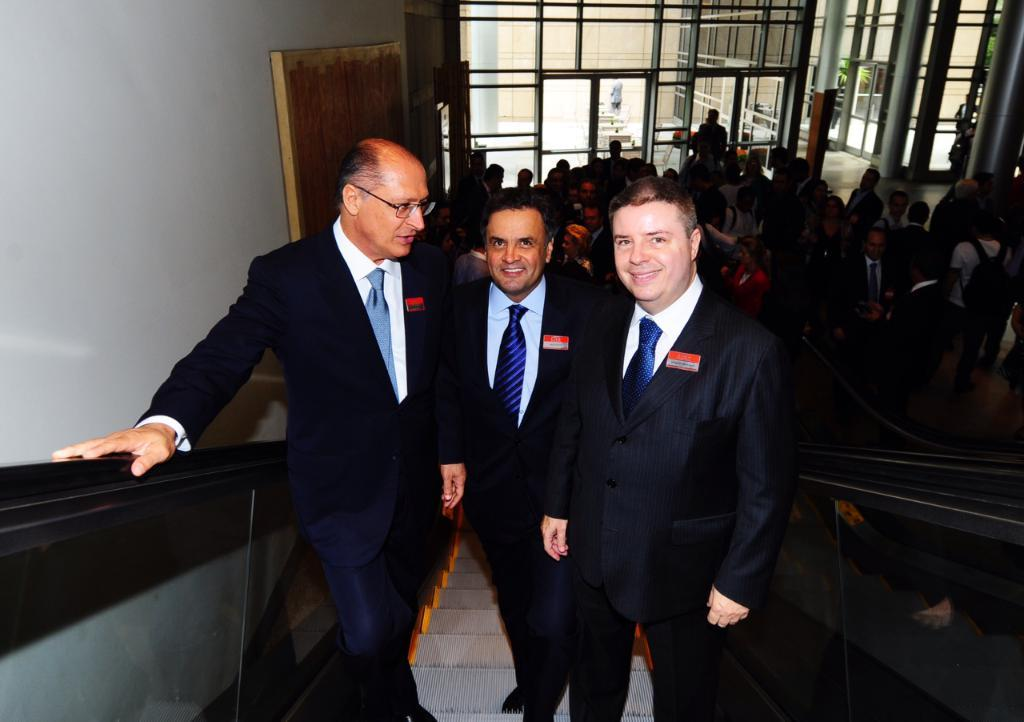How many men are in the image? There are three men in the image. What are the men doing in the image? The men are smiling in the image. Where are the men located in the image? The men are standing on an escalator in the image. What can be seen in the background of the image? In the background of the image, there is a group of people, pillars, walls, leaves, and some objects. What type of chin is visible on the escalator in the image? There is no chin visible on the escalator in the image; it is a group of men standing on the escalator. 